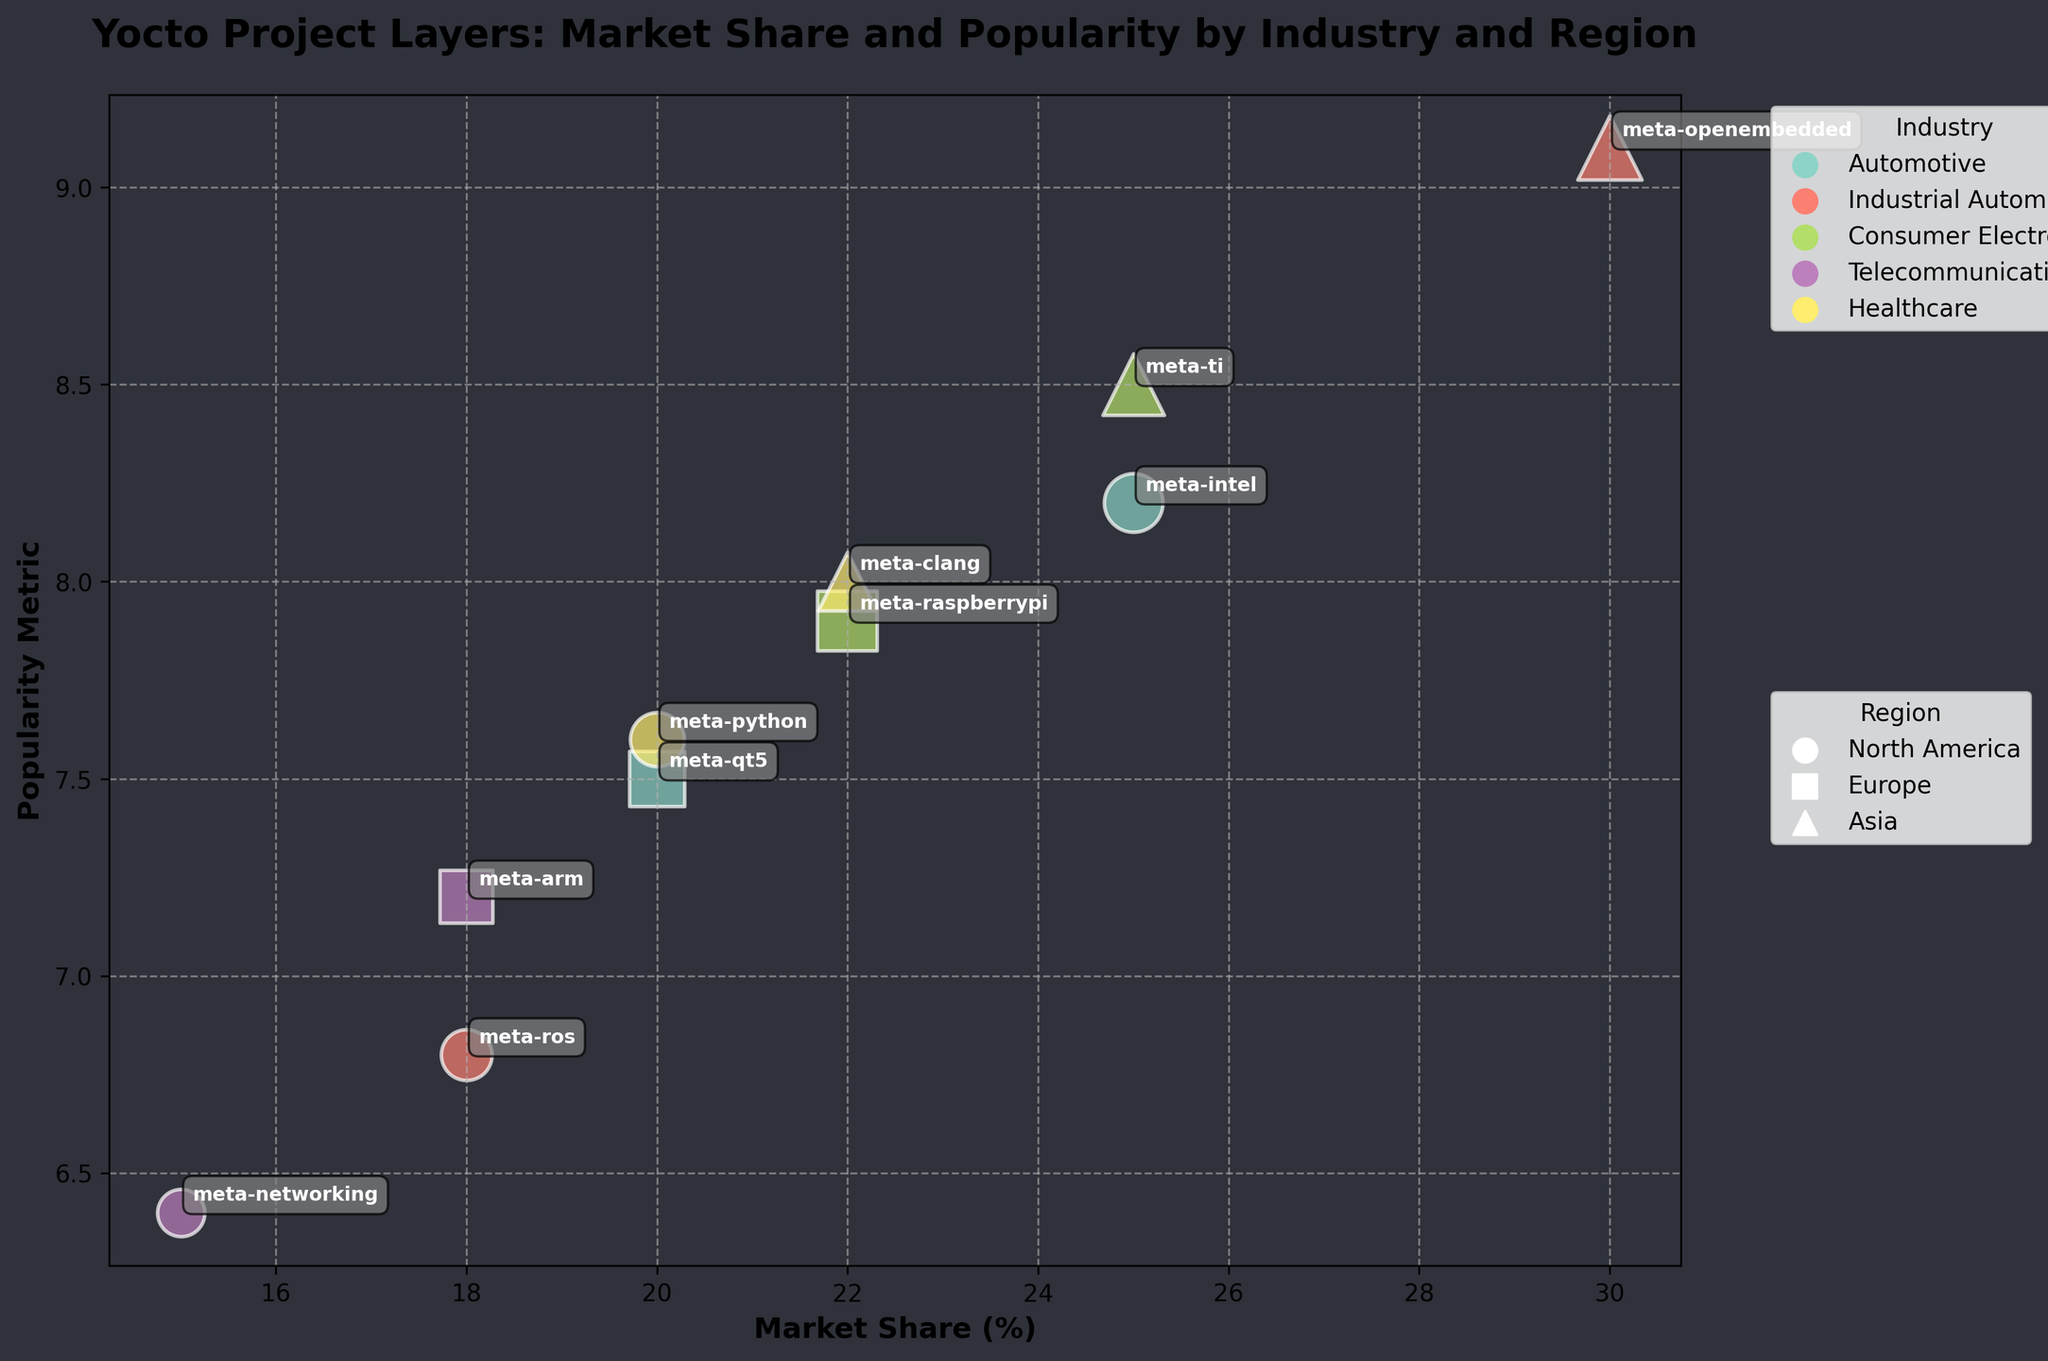How many different industries are represented in the bubble chart? The legend shows different colors for each industry. You can count the number of colors in the legend to determine the number of industries.
Answer: 5 Which layer has the highest Market Share in Asia? By checking the Market Share values for layers in Asia in the dataset, we find that "meta-openembedded" for Industrial Automation has the highest Market Share of 30.
Answer: meta-openembedded Which industry has the most layers represented in the bubble chart? Count the number of bubbles associated with each industry based on color. "Consumer Electronics" and "Healthcare" both have 2 layers, but "Automotive" has 2 layers and others have fewer. Hence, "Automotive" and "Consumer Electronics" have the most.
Answer: Automotive and Consumer Electronics What is the average Popularity Metric for Consumer Electronics layers? Sum the Popularity Metric values for "meta-raspberrypi" (7.9) and "meta-ti" (8.5) and divide by the number of layers (2). (7.9 + 8.5) / 2 = 8.2
Answer: 8.2 Compare the Market Share of meta-arm and meta-ros. Which one is higher? Look at the Market Share values for "meta-arm" (18) and "meta-ros" (18). Both layers have the same Market Share.
Answer: Equal Which region has the most diverse range of industries represented in the chart? Count the number of unique industries for each region by looking at different markers used. North America and Asia have more industries represented compared to Europe.
Answer: North America and Asia What is the total Bubble Size for layers in North America? Add the Bubble Sizes for all layers in North America: "meta-intel" (200), "meta-ros" (150), "meta-networking" (130), "meta-python" (170). 200 + 150 + 130 + 170 = 650
Answer: 650 Which layer has the highest Popularity Metric and which industry does it belong to? Find the highest Popularity Metric value in the dataset (9.1 for "meta-openembedded"). This layer belongs to Industrial Automation.
Answer: meta-openembedded; Industrial Automation How does the Market Share of meta-raspberrypi compare to that of meta-clang? Look at the Market Share values for "meta-raspberrypi" (22) and "meta-clang" (22). Both layers have equal Market Share.
Answer: Equal 